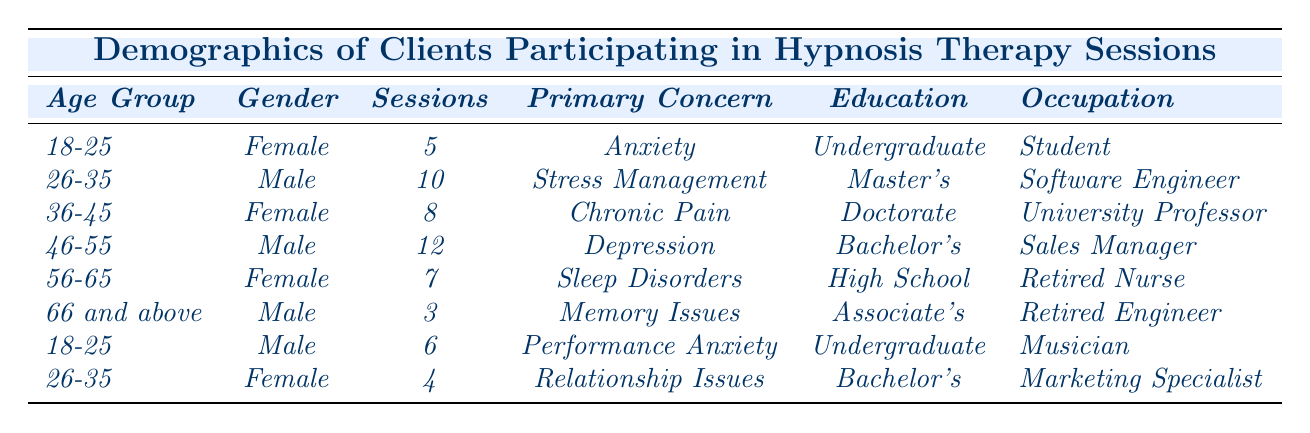What is the primary concern of clients aged 18-25? In the table, there are two clients in the age group 18-25. One is a female with a primary concern of Anxiety, and the other is a male with a primary concern of Performance Anxiety.
Answer: Anxiety and Performance Anxiety How many sessions did the male client aged 46-55 attend? Referring to the table, the male client in the age group 46-55 attended 12 sessions.
Answer: 12 What is the average session count of clients in the age group 26-35? For the age group 26-35, there are two clients: one male with 10 sessions and one female with 4 sessions. To find the average, add those values (10 + 4 = 14) and divide by the number of clients (2). Therefore, the average is 14/2 = 7.
Answer: 7 Is there a female client with a doctorate degree in the table? According to the table, there is one female client aged 36-45 who has a doctorate degree.
Answer: Yes Which occupation corresponds to the client with the highest session count? The client with the highest session count is the male aged 46-55, who is a Sales Manager with 12 sessions.
Answer: Sales Manager What is the difference in session count between the youngest and oldest clients in the table? The youngest clients are aged 18-25 with session counts of 5 and 6, and the oldest client is aged 66 and above with 3 sessions. To find the difference, first calculate the total sessions for the youngest (5 + 6 = 11) and then subtract the oldest client's sessions (11 - 3 = 8).
Answer: 8 How many clients in total have concerns related to anxiety? From the table, two clients have primary concerns related to anxiety: one female in the 18-25 age group (Anxiety) and one male in the 18-25 age group (Performance Anxiety). Thus, the total is 2 clients.
Answer: 2 What percentage of clients in the table have a master's degree? There are a total of 8 clients in the table. Out of these, only 1 client has a master's degree (the male 26-35). To find the percentage, divide the number of master's degree holders by the total number of clients and multiply by 100: (1/8) * 100 = 12.5%.
Answer: 12.5% Do most clients in the table express concerns regarding stress or anxiety? The table shows that there are two clients with anxiety-related concerns (Anxiety and Performance Anxiety) and one client with a concern of Stress Management. Thus, anxiety-related concerns (2) are greater than stress concerns (1).
Answer: Yes What is the most common occupation among clients in the age group 56-65? There is only one client aged 56-65 listed in the table, who is a Retired Nurse. Since there is no other occupation in this age group, this is deemed the most common.
Answer: Retired Nurse 